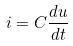Convert formula to latex. <formula><loc_0><loc_0><loc_500><loc_500>i = C \frac { d u } { d t }</formula> 